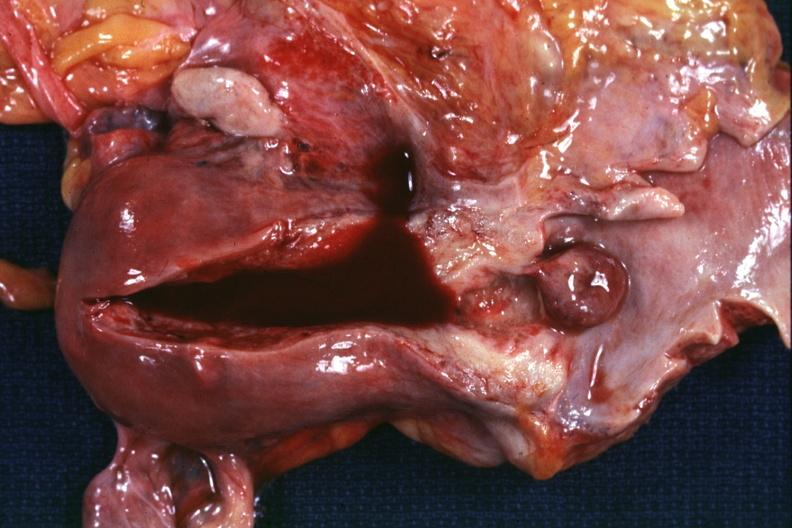s female reproductive present?
Answer the question using a single word or phrase. Yes 